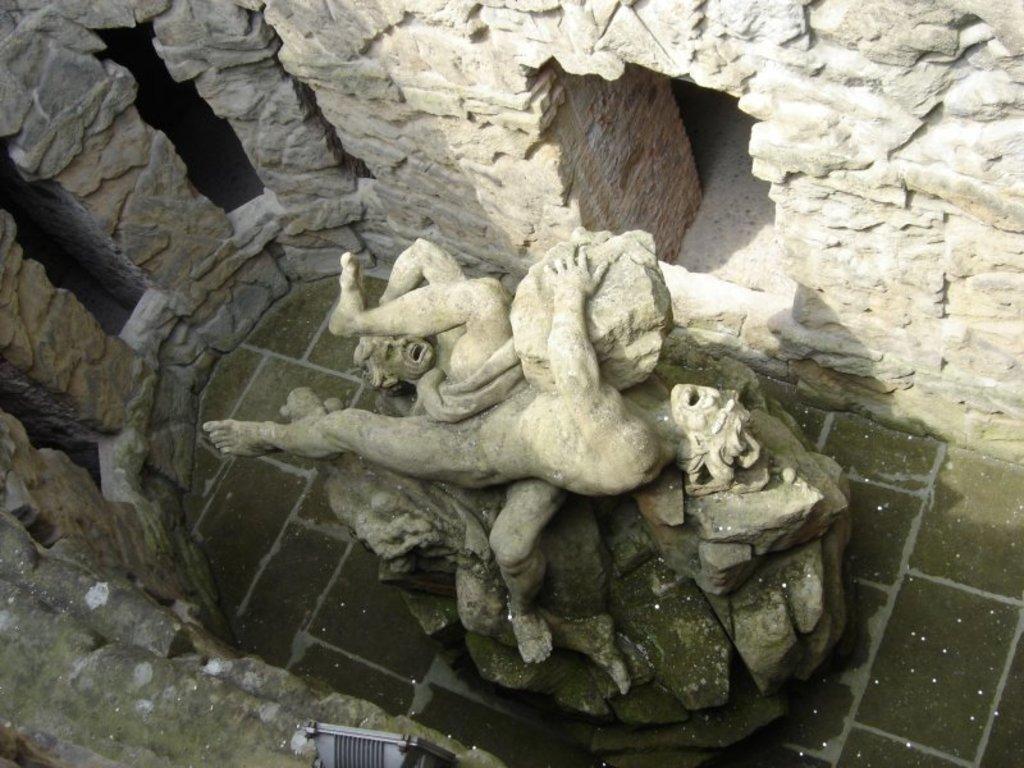Can you describe this image briefly? In this image I can see the statue of two persons and a rock which is ash in color. I can see rock walls around the statue and I can see the black colored object. 